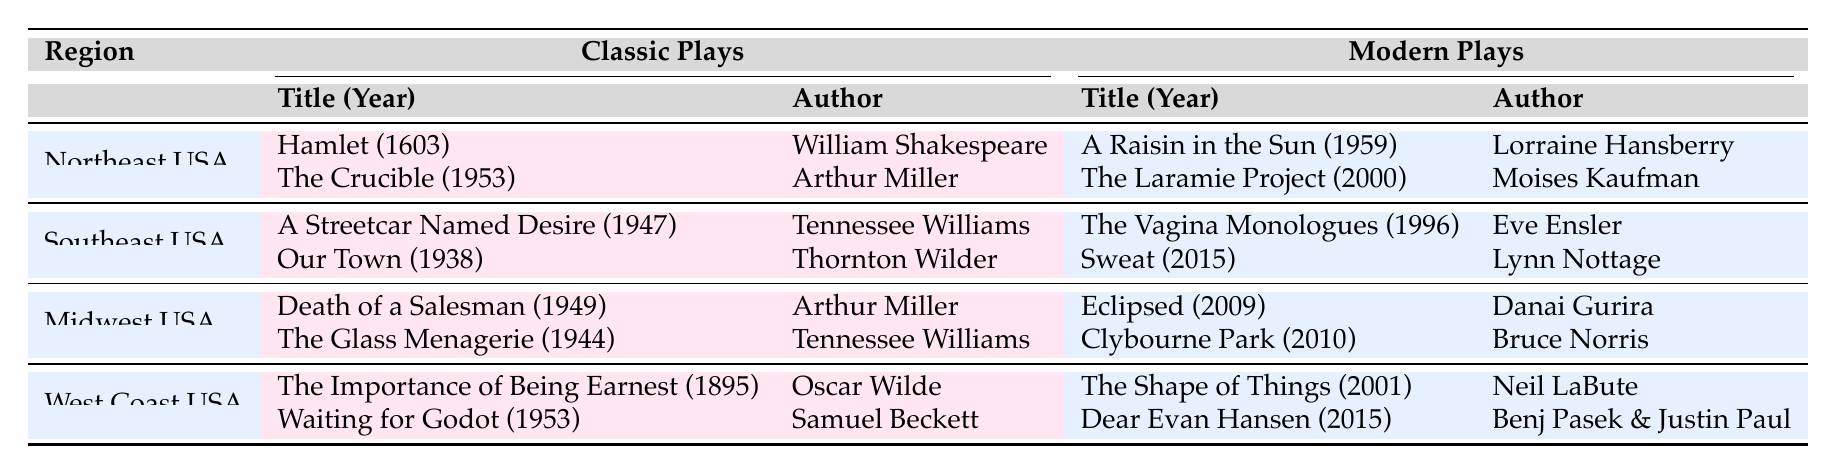What classic play by Arthur Miller is included in the Northeast USA curriculum? In the table, I can find the Northeast USA region listed, where the classic plays are under that specific row. The classic plays include "Hamlet" by William Shakespeare and "The Crucible" by Arthur Miller. Thus, the answer is "The Crucible."
Answer: The Crucible Which region features "Sweat" and "The Vagina Monologues"? The table shows that "Sweat" and "The Vagina Monologues" are both listed under the modern plays section in the Southeast USA region. By examining that row, I can confirm that these modern plays correspond to this specific region.
Answer: Southeast USA Is "Waiting for Godot" the only classic play by Samuel Beckett in the table? The table lists "Waiting for Godot" as one of the classic plays in the West Coast USA region, but I need to check if there are any other plays by Samuel Beckett included. Looking at the table, there is only one entry for classic plays attributed to him, thus the statement is true.
Answer: Yes How many classic plays are listed in total across all regions? I need to count the classic plays in each region based on the table's entries. The Northeast USA has 2, Southeast USA has 2, Midwest USA has 2, and West Coast USA has 2 classic plays. Summing these gives a total of 2 + 2 + 2 + 2 = 8.
Answer: 8 Which modern play by Danai Gurira is included in the Midwest USA curriculum? In the Midwest USA row, I can see that among the modern plays listed, "Eclipsed" by Danai Gurira is mentioned. I locate this specific play under the modern plays section of that region.
Answer: Eclipsed What is the year of publication for "Dear Evan Hansen"? By locating the West Coast USA region in the table, I find that "Dear Evan Hansen" is listed as a modern play, and it was published in 2015. Therefore, the year of publication can be confirmed from this entry.
Answer: 2015 Are there more modern plays listed than classic plays in the Southeast USA region? I will check the Southeast USA row in the table, where both classic and modern plays are listed. There are 2 classic plays and 2 modern plays listed for this region. Since both quantities are equal, the answer to the question is no.
Answer: No What is the average year of publication for modern plays in the table? I will add the years of publication for the modern plays listed: 1959 (A Raisin in the Sun) + 2000 (The Laramie Project) + 1996 (The Vagina Monologues) + 2015 (Sweat) + 2009 (Eclipsed) + 2010 (Clybourne Park) + 2001 (The Shape of Things) + 2015 (Dear Evan Hansen) = 15 years. To find the average, I count 8 modern plays and divide the total by 8. The average year is computed as (1959 + 2000 + 1996 + 2015 + 2009 + 2010 + 2001 + 2015) / 8 = 2004.
Answer: 2004 